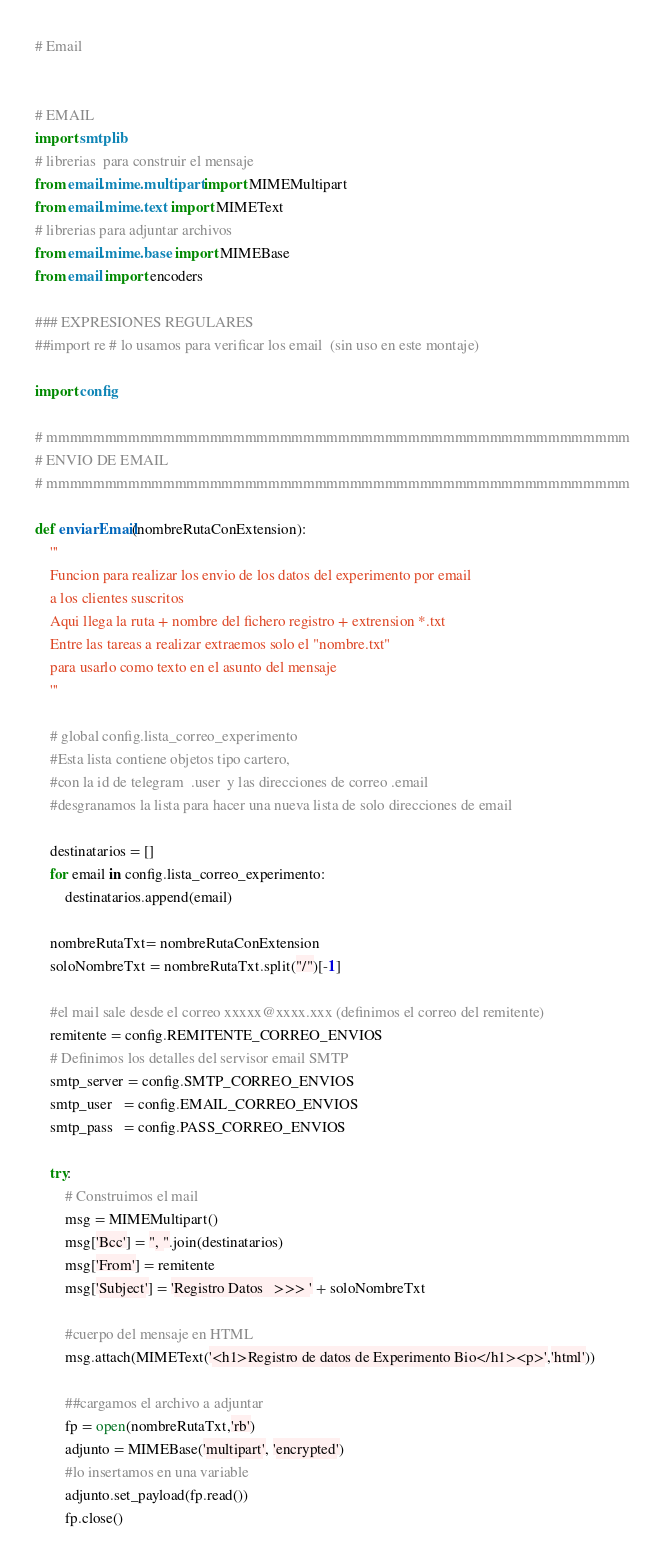Convert code to text. <code><loc_0><loc_0><loc_500><loc_500><_Python_># Email


# EMAIL
import smtplib
# librerias  para construir el mensaje
from email.mime.multipart import MIMEMultipart
from email.mime.text import MIMEText 
# librerias para adjuntar archivos
from email.mime.base import MIMEBase
from email import encoders 

### EXPRESIONES REGULARES
##import re # lo usamos para verificar los email  (sin uso en este montaje)

import config

# mmmmmmmmmmmmmmmmmmmmmmmmmmmmmmmmmmmmmmmmmmmmmmmmmm
# ENVIO DE EMAIL
# mmmmmmmmmmmmmmmmmmmmmmmmmmmmmmmmmmmmmmmmmmmmmmmmmm

def enviarEmail(nombreRutaConExtension):
    '''
    Funcion para realizar los envio de los datos del experimento por email
    a los clientes suscritos
    Aqui llega la ruta + nombre del fichero registro + extrension *.txt
    Entre las tareas a realizar extraemos solo el "nombre.txt"
    para usarlo como texto en el asunto del mensaje
    '''

    # global config.lista_correo_experimento
    #Esta lista contiene objetos tipo cartero,
    #con la id de telegram  .user  y las direcciones de correo .email
    #desgranamos la lista para hacer una nueva lista de solo direcciones de email
    
    destinatarios = []
    for email in config.lista_correo_experimento:
        destinatarios.append(email)
        
    nombreRutaTxt= nombreRutaConExtension
    soloNombreTxt = nombreRutaTxt.split("/")[-1]

    #el mail sale desde el correo xxxxx@xxxx.xxx (definimos el correo del remitente)
    remitente = config.REMITENTE_CORREO_ENVIOS
    # Definimos los detalles del servisor email SMTP
    smtp_server = config.SMTP_CORREO_ENVIOS
    smtp_user   = config.EMAIL_CORREO_ENVIOS
    smtp_pass   = config.PASS_CORREO_ENVIOS

    try: 
        # Construimos el mail
        msg = MIMEMultipart() 
        msg['Bcc'] = ", ".join(destinatarios)
        msg['From'] = remitente
        msg['Subject'] = 'Registro Datos   >>> ' + soloNombreTxt

        #cuerpo del mensaje en HTML
        msg.attach(MIMEText('<h1>Registro de datos de Experimento Bio</h1><p>','html'))

        ##cargamos el archivo a adjuntar
        fp = open(nombreRutaTxt,'rb')
        adjunto = MIMEBase('multipart', 'encrypted')
        #lo insertamos en una variable
        adjunto.set_payload(fp.read()) 
        fp.close()  </code> 